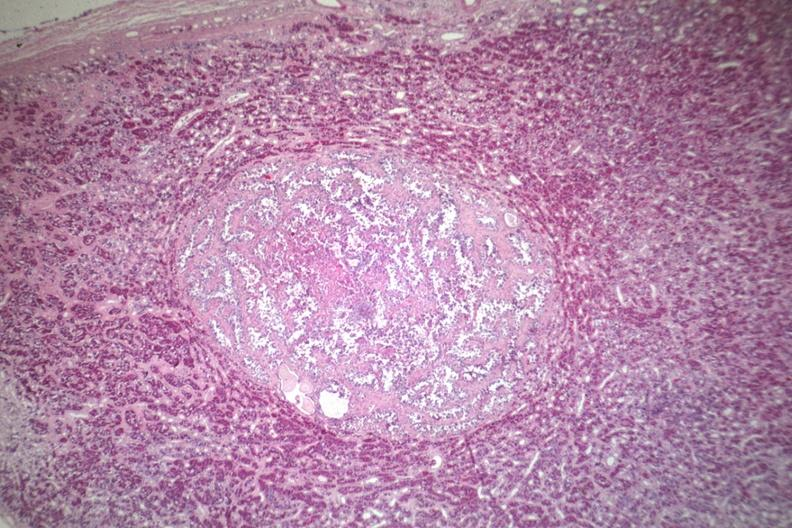what is present?
Answer the question using a single word or phrase. Adenoma 